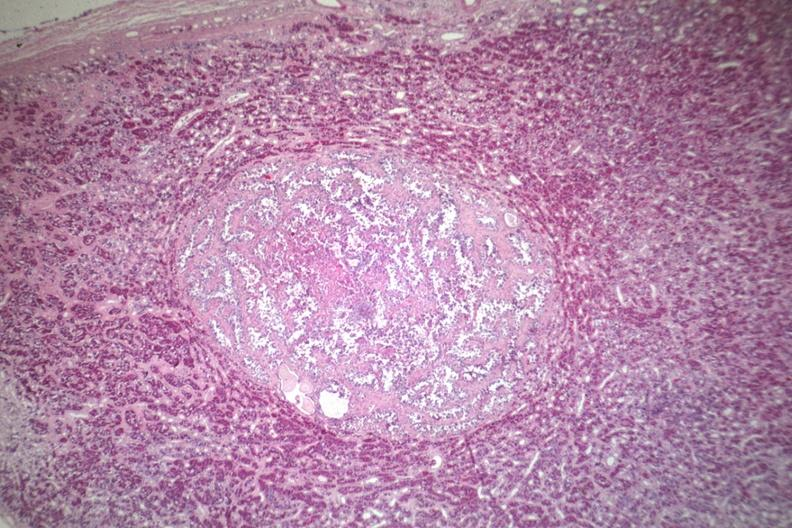what is present?
Answer the question using a single word or phrase. Adenoma 